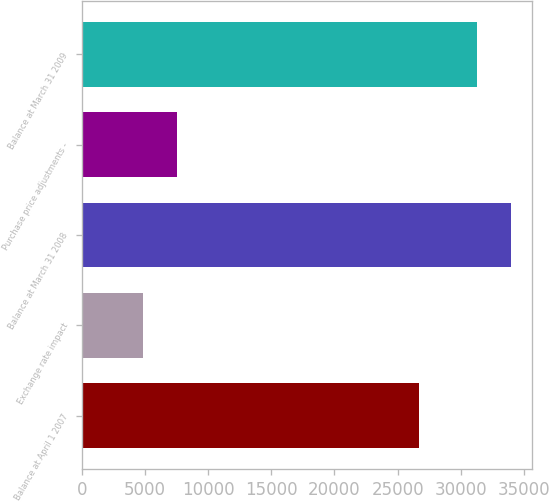Convert chart. <chart><loc_0><loc_0><loc_500><loc_500><bar_chart><fcel>Balance at April 1 2007<fcel>Exchange rate impact<fcel>Balance at March 31 2008<fcel>Purchase price adjustments -<fcel>Balance at March 31 2009<nl><fcel>26708<fcel>4855<fcel>33965.8<fcel>7525.8<fcel>31295<nl></chart> 